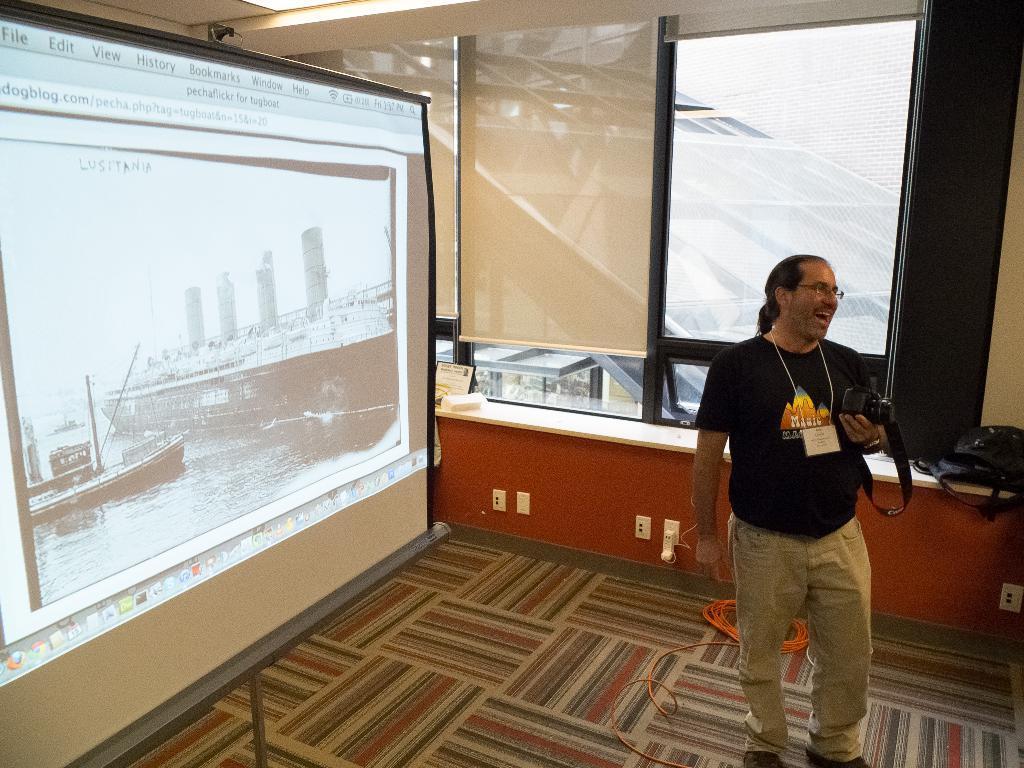In one or two sentences, can you explain what this image depicts? In this image I can see a person is standing on the floor and is holding a camera in hand. In the background I can see a screen, stand, window, desk, metal rods and lights. This image is taken may be in a hall. 